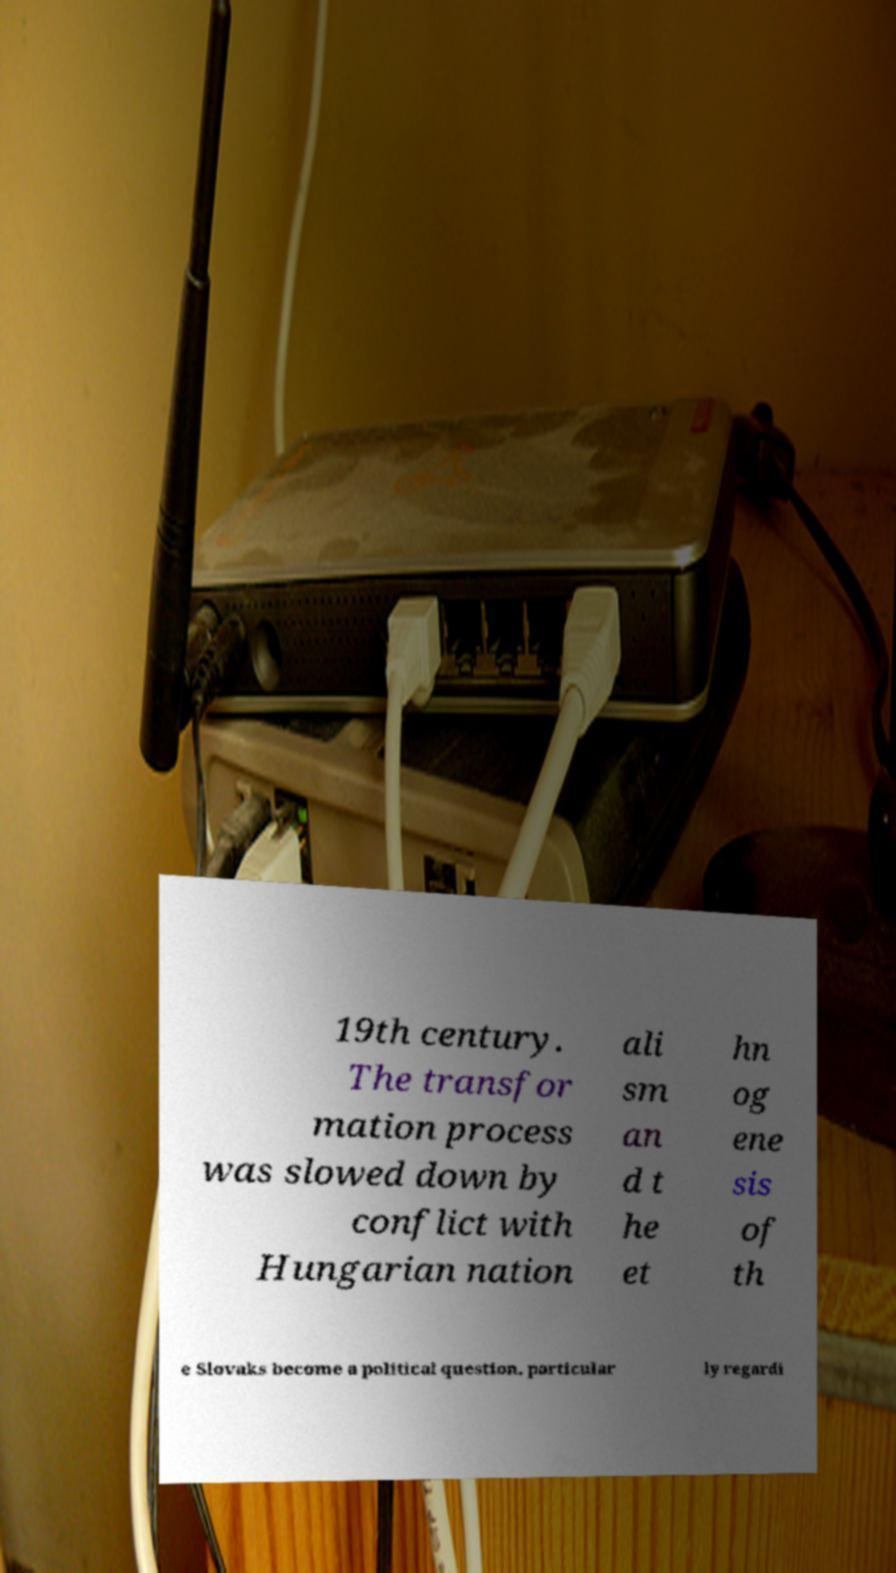Please identify and transcribe the text found in this image. 19th century. The transfor mation process was slowed down by conflict with Hungarian nation ali sm an d t he et hn og ene sis of th e Slovaks become a political question, particular ly regardi 